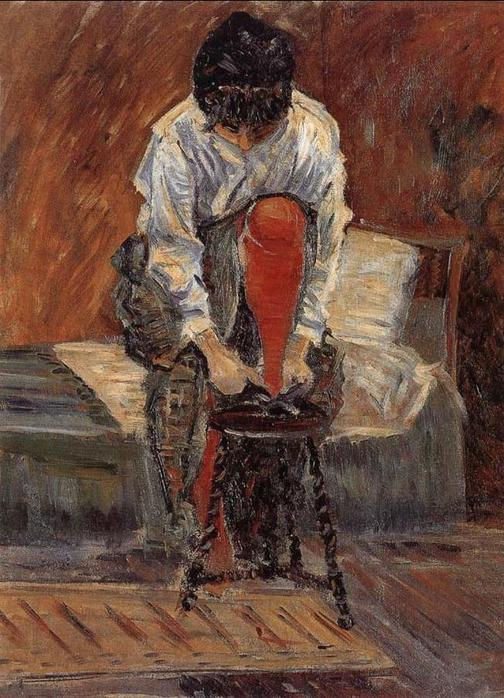Imagine a brief yet realistic scenario for this image. Eleanor just came home after running errands. She sits on her chair to take off her shoes, enjoying a rare moment of rest in her busy day. 